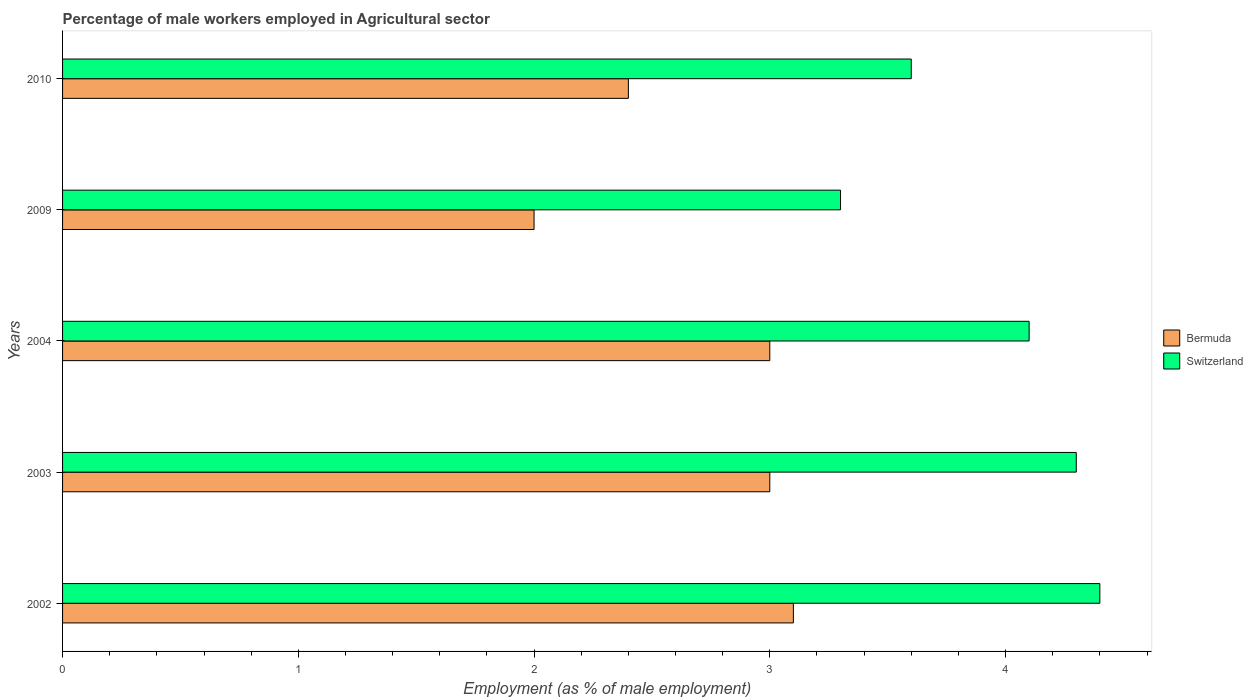How many groups of bars are there?
Your answer should be very brief. 5. How many bars are there on the 2nd tick from the top?
Provide a succinct answer. 2. How many bars are there on the 1st tick from the bottom?
Provide a short and direct response. 2. What is the percentage of male workers employed in Agricultural sector in Switzerland in 2003?
Offer a terse response. 4.3. Across all years, what is the maximum percentage of male workers employed in Agricultural sector in Bermuda?
Provide a succinct answer. 3.1. Across all years, what is the minimum percentage of male workers employed in Agricultural sector in Bermuda?
Offer a terse response. 2. In which year was the percentage of male workers employed in Agricultural sector in Switzerland minimum?
Your answer should be compact. 2009. What is the total percentage of male workers employed in Agricultural sector in Bermuda in the graph?
Offer a terse response. 13.5. What is the difference between the percentage of male workers employed in Agricultural sector in Switzerland in 2002 and that in 2004?
Ensure brevity in your answer.  0.3. What is the difference between the percentage of male workers employed in Agricultural sector in Switzerland in 2004 and the percentage of male workers employed in Agricultural sector in Bermuda in 2010?
Keep it short and to the point. 1.7. What is the average percentage of male workers employed in Agricultural sector in Switzerland per year?
Give a very brief answer. 3.94. In the year 2002, what is the difference between the percentage of male workers employed in Agricultural sector in Switzerland and percentage of male workers employed in Agricultural sector in Bermuda?
Your answer should be very brief. 1.3. In how many years, is the percentage of male workers employed in Agricultural sector in Bermuda greater than 2.6 %?
Ensure brevity in your answer.  3. What is the ratio of the percentage of male workers employed in Agricultural sector in Switzerland in 2009 to that in 2010?
Offer a terse response. 0.92. What is the difference between the highest and the second highest percentage of male workers employed in Agricultural sector in Switzerland?
Provide a succinct answer. 0.1. What is the difference between the highest and the lowest percentage of male workers employed in Agricultural sector in Switzerland?
Ensure brevity in your answer.  1.1. Is the sum of the percentage of male workers employed in Agricultural sector in Switzerland in 2002 and 2009 greater than the maximum percentage of male workers employed in Agricultural sector in Bermuda across all years?
Your answer should be compact. Yes. What does the 2nd bar from the top in 2002 represents?
Provide a short and direct response. Bermuda. What does the 1st bar from the bottom in 2004 represents?
Your answer should be compact. Bermuda. How many bars are there?
Provide a short and direct response. 10. How many years are there in the graph?
Offer a very short reply. 5. What is the difference between two consecutive major ticks on the X-axis?
Give a very brief answer. 1. What is the title of the graph?
Offer a terse response. Percentage of male workers employed in Agricultural sector. What is the label or title of the X-axis?
Offer a terse response. Employment (as % of male employment). What is the label or title of the Y-axis?
Ensure brevity in your answer.  Years. What is the Employment (as % of male employment) in Bermuda in 2002?
Provide a short and direct response. 3.1. What is the Employment (as % of male employment) of Switzerland in 2002?
Your response must be concise. 4.4. What is the Employment (as % of male employment) of Bermuda in 2003?
Ensure brevity in your answer.  3. What is the Employment (as % of male employment) in Switzerland in 2003?
Your answer should be compact. 4.3. What is the Employment (as % of male employment) of Bermuda in 2004?
Offer a terse response. 3. What is the Employment (as % of male employment) of Switzerland in 2004?
Provide a succinct answer. 4.1. What is the Employment (as % of male employment) of Switzerland in 2009?
Ensure brevity in your answer.  3.3. What is the Employment (as % of male employment) of Bermuda in 2010?
Give a very brief answer. 2.4. What is the Employment (as % of male employment) in Switzerland in 2010?
Your answer should be compact. 3.6. Across all years, what is the maximum Employment (as % of male employment) in Bermuda?
Make the answer very short. 3.1. Across all years, what is the maximum Employment (as % of male employment) in Switzerland?
Offer a terse response. 4.4. Across all years, what is the minimum Employment (as % of male employment) in Bermuda?
Your response must be concise. 2. Across all years, what is the minimum Employment (as % of male employment) in Switzerland?
Your answer should be very brief. 3.3. What is the total Employment (as % of male employment) of Switzerland in the graph?
Give a very brief answer. 19.7. What is the difference between the Employment (as % of male employment) in Bermuda in 2002 and that in 2003?
Your answer should be very brief. 0.1. What is the difference between the Employment (as % of male employment) of Switzerland in 2002 and that in 2003?
Your answer should be compact. 0.1. What is the difference between the Employment (as % of male employment) in Switzerland in 2002 and that in 2004?
Keep it short and to the point. 0.3. What is the difference between the Employment (as % of male employment) in Switzerland in 2002 and that in 2009?
Ensure brevity in your answer.  1.1. What is the difference between the Employment (as % of male employment) of Bermuda in 2003 and that in 2009?
Make the answer very short. 1. What is the difference between the Employment (as % of male employment) of Switzerland in 2003 and that in 2009?
Keep it short and to the point. 1. What is the difference between the Employment (as % of male employment) of Switzerland in 2003 and that in 2010?
Give a very brief answer. 0.7. What is the difference between the Employment (as % of male employment) in Bermuda in 2004 and that in 2010?
Offer a terse response. 0.6. What is the difference between the Employment (as % of male employment) in Switzerland in 2004 and that in 2010?
Make the answer very short. 0.5. What is the difference between the Employment (as % of male employment) of Bermuda in 2002 and the Employment (as % of male employment) of Switzerland in 2004?
Your answer should be compact. -1. What is the difference between the Employment (as % of male employment) of Bermuda in 2002 and the Employment (as % of male employment) of Switzerland in 2009?
Make the answer very short. -0.2. What is the difference between the Employment (as % of male employment) in Bermuda in 2002 and the Employment (as % of male employment) in Switzerland in 2010?
Keep it short and to the point. -0.5. What is the difference between the Employment (as % of male employment) in Bermuda in 2003 and the Employment (as % of male employment) in Switzerland in 2004?
Give a very brief answer. -1.1. What is the difference between the Employment (as % of male employment) in Bermuda in 2003 and the Employment (as % of male employment) in Switzerland in 2009?
Your answer should be compact. -0.3. What is the difference between the Employment (as % of male employment) of Bermuda in 2003 and the Employment (as % of male employment) of Switzerland in 2010?
Ensure brevity in your answer.  -0.6. What is the difference between the Employment (as % of male employment) in Bermuda in 2004 and the Employment (as % of male employment) in Switzerland in 2009?
Your answer should be very brief. -0.3. What is the average Employment (as % of male employment) of Bermuda per year?
Keep it short and to the point. 2.7. What is the average Employment (as % of male employment) of Switzerland per year?
Make the answer very short. 3.94. In the year 2002, what is the difference between the Employment (as % of male employment) of Bermuda and Employment (as % of male employment) of Switzerland?
Give a very brief answer. -1.3. In the year 2003, what is the difference between the Employment (as % of male employment) of Bermuda and Employment (as % of male employment) of Switzerland?
Offer a terse response. -1.3. In the year 2009, what is the difference between the Employment (as % of male employment) of Bermuda and Employment (as % of male employment) of Switzerland?
Your answer should be compact. -1.3. In the year 2010, what is the difference between the Employment (as % of male employment) in Bermuda and Employment (as % of male employment) in Switzerland?
Provide a succinct answer. -1.2. What is the ratio of the Employment (as % of male employment) of Switzerland in 2002 to that in 2003?
Offer a very short reply. 1.02. What is the ratio of the Employment (as % of male employment) of Bermuda in 2002 to that in 2004?
Make the answer very short. 1.03. What is the ratio of the Employment (as % of male employment) in Switzerland in 2002 to that in 2004?
Keep it short and to the point. 1.07. What is the ratio of the Employment (as % of male employment) in Bermuda in 2002 to that in 2009?
Ensure brevity in your answer.  1.55. What is the ratio of the Employment (as % of male employment) of Switzerland in 2002 to that in 2009?
Give a very brief answer. 1.33. What is the ratio of the Employment (as % of male employment) of Bermuda in 2002 to that in 2010?
Make the answer very short. 1.29. What is the ratio of the Employment (as % of male employment) of Switzerland in 2002 to that in 2010?
Provide a succinct answer. 1.22. What is the ratio of the Employment (as % of male employment) of Switzerland in 2003 to that in 2004?
Your answer should be compact. 1.05. What is the ratio of the Employment (as % of male employment) in Switzerland in 2003 to that in 2009?
Offer a very short reply. 1.3. What is the ratio of the Employment (as % of male employment) in Switzerland in 2003 to that in 2010?
Ensure brevity in your answer.  1.19. What is the ratio of the Employment (as % of male employment) of Bermuda in 2004 to that in 2009?
Keep it short and to the point. 1.5. What is the ratio of the Employment (as % of male employment) of Switzerland in 2004 to that in 2009?
Ensure brevity in your answer.  1.24. What is the ratio of the Employment (as % of male employment) of Switzerland in 2004 to that in 2010?
Provide a succinct answer. 1.14. What is the ratio of the Employment (as % of male employment) in Switzerland in 2009 to that in 2010?
Your response must be concise. 0.92. What is the difference between the highest and the second highest Employment (as % of male employment) of Switzerland?
Keep it short and to the point. 0.1. What is the difference between the highest and the lowest Employment (as % of male employment) in Switzerland?
Keep it short and to the point. 1.1. 